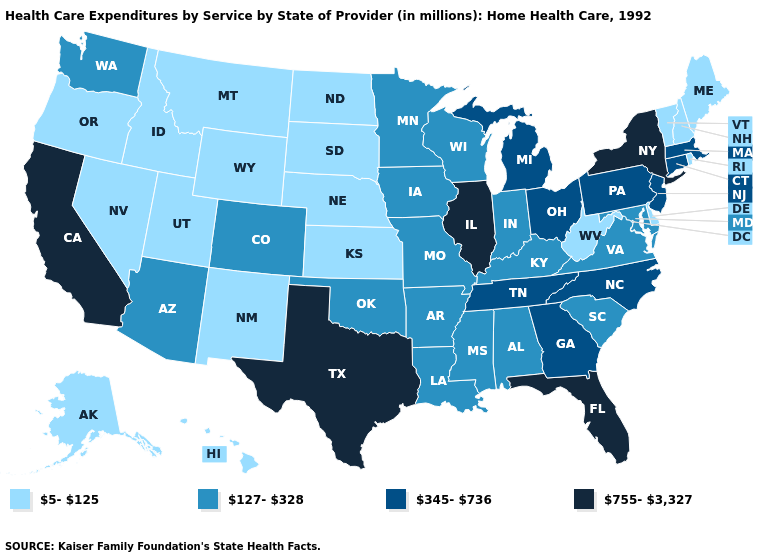What is the value of Kentucky?
Concise answer only. 127-328. What is the value of Nebraska?
Short answer required. 5-125. Does the map have missing data?
Short answer required. No. Name the states that have a value in the range 127-328?
Concise answer only. Alabama, Arizona, Arkansas, Colorado, Indiana, Iowa, Kentucky, Louisiana, Maryland, Minnesota, Mississippi, Missouri, Oklahoma, South Carolina, Virginia, Washington, Wisconsin. Name the states that have a value in the range 127-328?
Answer briefly. Alabama, Arizona, Arkansas, Colorado, Indiana, Iowa, Kentucky, Louisiana, Maryland, Minnesota, Mississippi, Missouri, Oklahoma, South Carolina, Virginia, Washington, Wisconsin. What is the lowest value in the MidWest?
Write a very short answer. 5-125. What is the value of Maine?
Give a very brief answer. 5-125. Which states hav the highest value in the MidWest?
Short answer required. Illinois. What is the value of Minnesota?
Answer briefly. 127-328. Which states have the lowest value in the West?
Give a very brief answer. Alaska, Hawaii, Idaho, Montana, Nevada, New Mexico, Oregon, Utah, Wyoming. Name the states that have a value in the range 127-328?
Answer briefly. Alabama, Arizona, Arkansas, Colorado, Indiana, Iowa, Kentucky, Louisiana, Maryland, Minnesota, Mississippi, Missouri, Oklahoma, South Carolina, Virginia, Washington, Wisconsin. Name the states that have a value in the range 345-736?
Answer briefly. Connecticut, Georgia, Massachusetts, Michigan, New Jersey, North Carolina, Ohio, Pennsylvania, Tennessee. Does North Carolina have the lowest value in the South?
Give a very brief answer. No. Name the states that have a value in the range 345-736?
Short answer required. Connecticut, Georgia, Massachusetts, Michigan, New Jersey, North Carolina, Ohio, Pennsylvania, Tennessee. Does Nevada have the lowest value in the USA?
Give a very brief answer. Yes. 